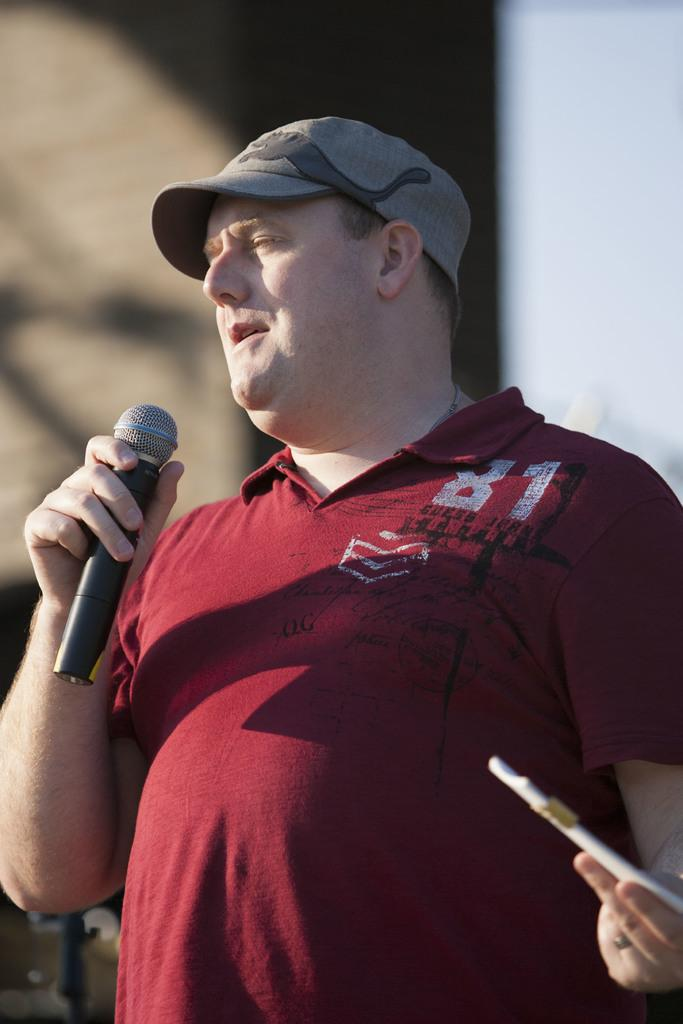What is the main subject of the image? There is a person in the image. What is the person wearing? The person is wearing a red shirt. What object is the person holding in his hand? The person is holding a microphone in his hand. What type of scarecrow is present in the image? There is no scarecrow present in the image; it features a person holding a microphone. What type of laborer is depicted in the image? The image does not depict a laborer; it features a person holding a microphone. 